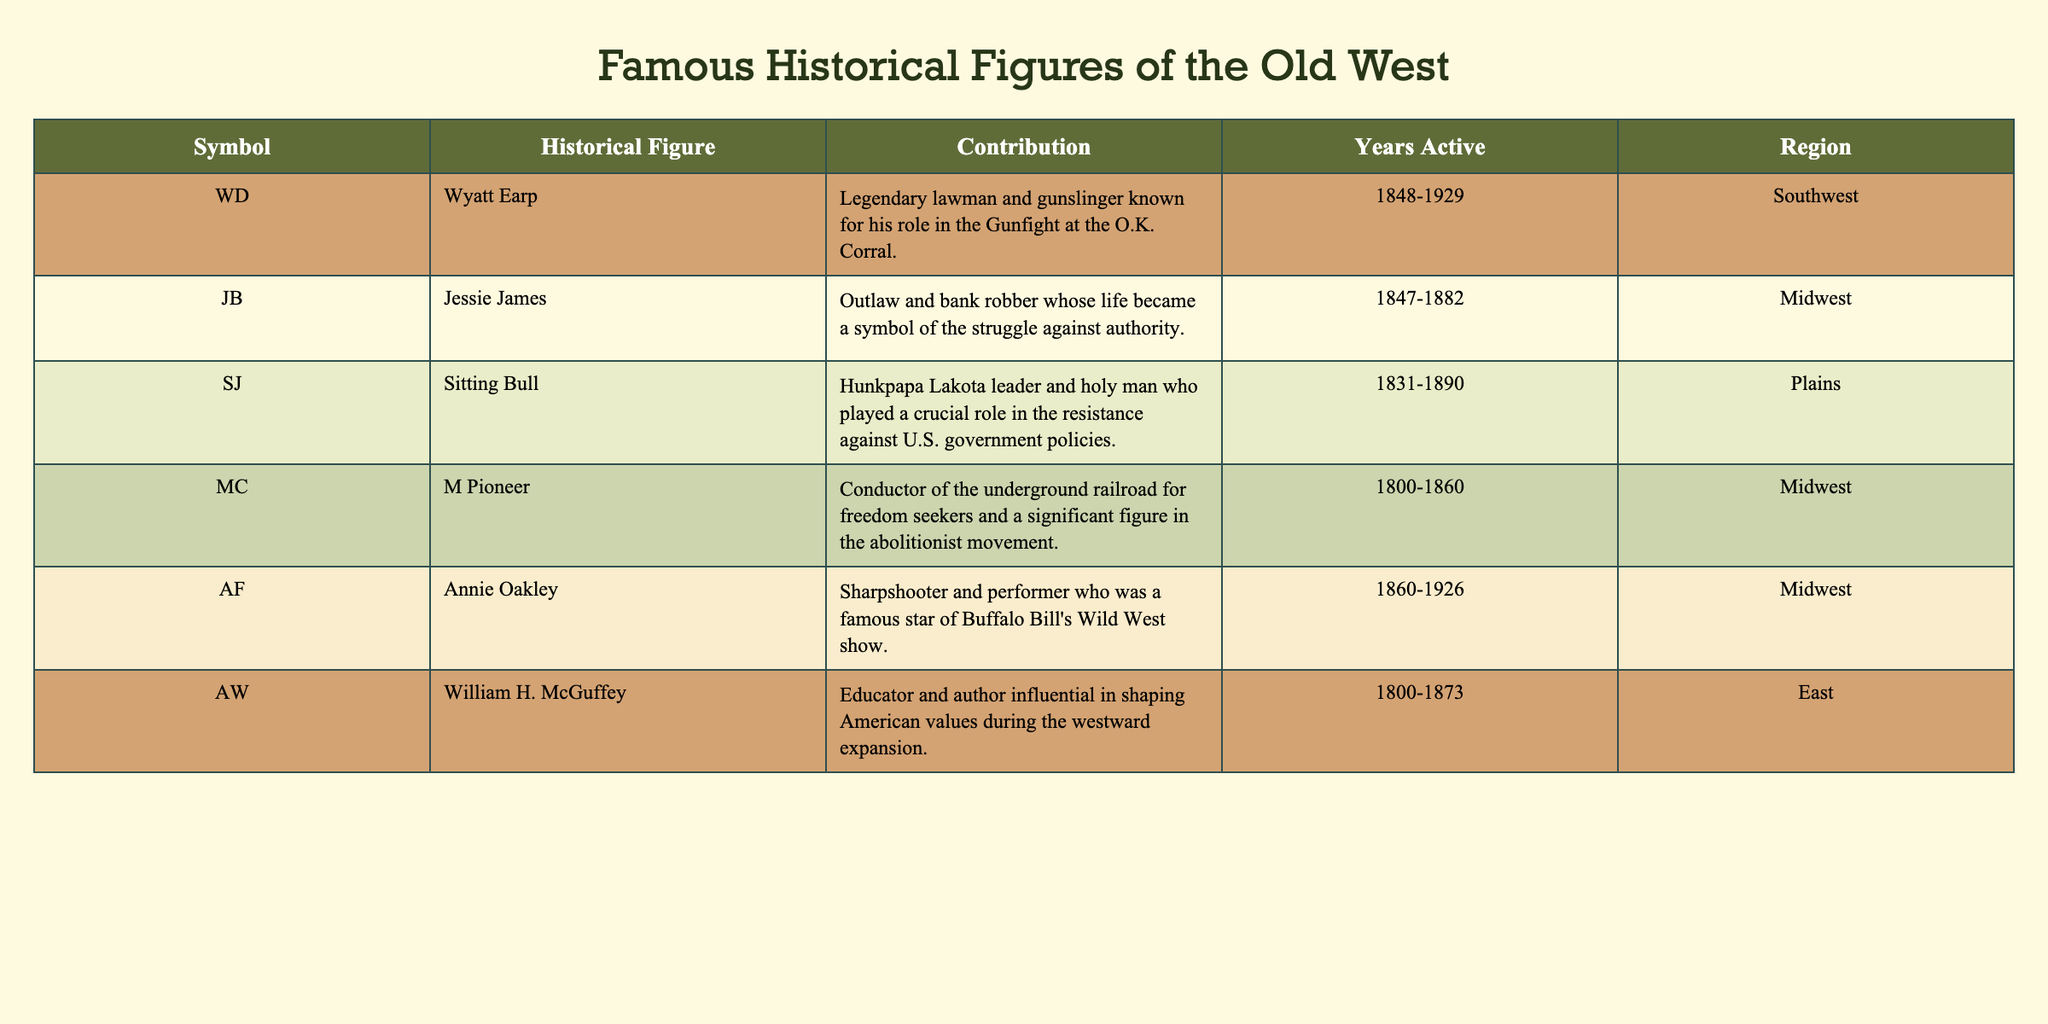What is the contribution of Wyatt Earp? According to the table, Wyatt Earp is described as a "Legendary lawman and gunslinger known for his role in the Gunfight at the O.K. Corral." This can be directly read in the 'Contribution' column corresponding to the 'Symbol' F2.
Answer: Legendary lawman and gunslinger known for his role in the Gunfight at the O.K. Corral Which historical figure was active the longest? The years active for each historical figure are indicated. Wyatt Earp was active from 1848 to 1929 (81 years), Jessie James from 1847 to 1882 (35 years), Sitting Bull from 1831 to 1890 (59 years), M Pioneer from 1800 to 1860 (60 years), Annie Oakley from 1860 to 1926 (66 years), and William H. McGuffey from 1800 to 1873 (73 years). Comparing these durations, Wyatt Earp has the longest active years at 81 years.
Answer: Wyatt Earp Did any historical figures contribute to education? To answer this, I can scan the 'Contribution' column for any mentions of education. William H. McGuffey is noted as "Educator and author influential in shaping American values during the westward expansion," which indicates his contribution to education. Therefore, the answer is yes.
Answer: Yes How many historical figures were active in the Midwest? From the table, I will count the number of figures noted in the 'Region' column as being in the Midwest. Jessie James, M Pioneer, Annie Oakley, and William H. McGuffey are listed as active in the Midwest, totaling four individuals.
Answer: 4 Who had the earliest active years? To find out who had the earliest active years, I will look at the starting year from the 'Years Active' column. Wyatt Earp started in 1848, Jessie James in 1847, Sitting Bull in 1831, M Pioneer in 1800, Annie Oakley in 1860, and William H. McGuffey also in 1800. Comparing these years, M Pioneer had the earliest active years starting in 1800.
Answer: M Pioneer 